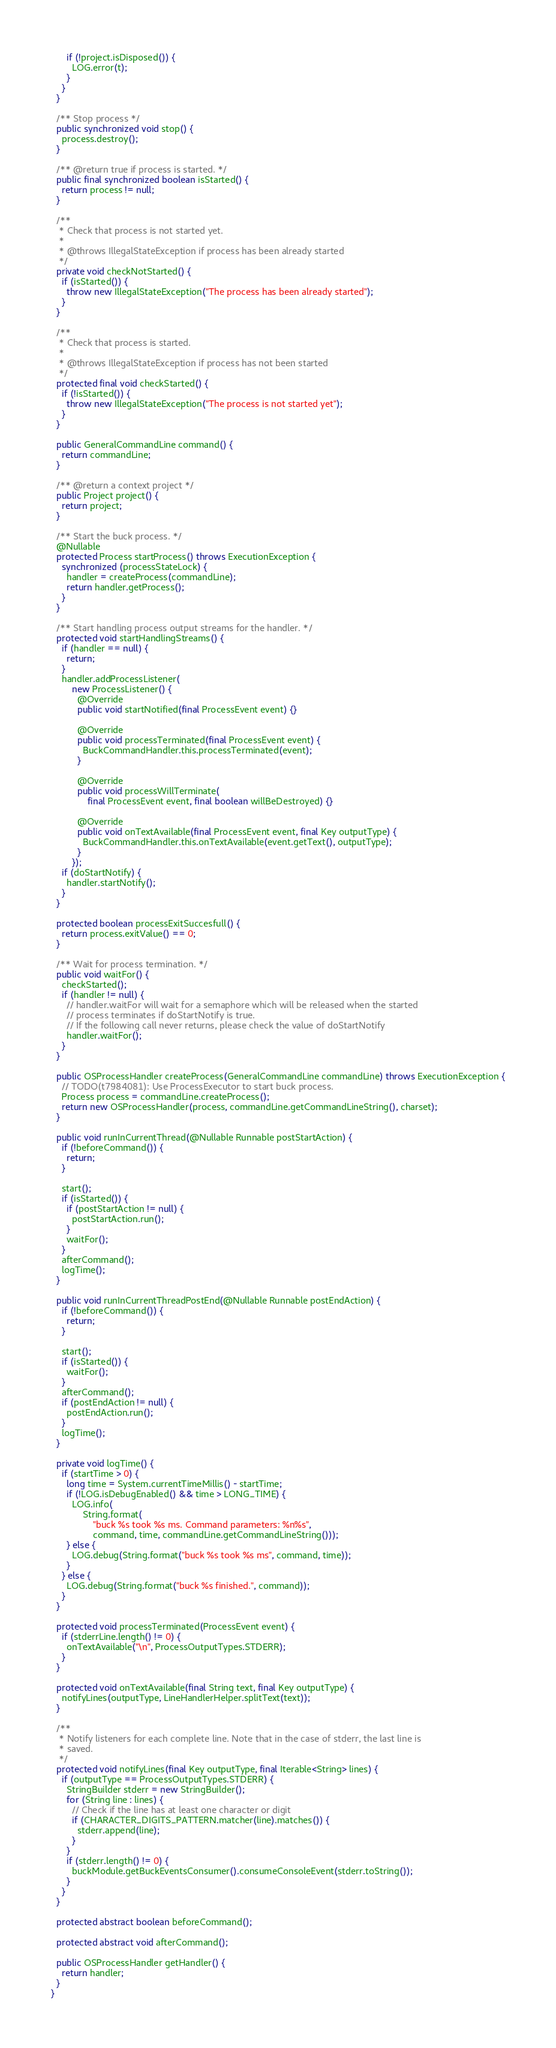<code> <loc_0><loc_0><loc_500><loc_500><_Java_>      if (!project.isDisposed()) {
        LOG.error(t);
      }
    }
  }

  /** Stop process */
  public synchronized void stop() {
    process.destroy();
  }

  /** @return true if process is started. */
  public final synchronized boolean isStarted() {
    return process != null;
  }

  /**
   * Check that process is not started yet.
   *
   * @throws IllegalStateException if process has been already started
   */
  private void checkNotStarted() {
    if (isStarted()) {
      throw new IllegalStateException("The process has been already started");
    }
  }

  /**
   * Check that process is started.
   *
   * @throws IllegalStateException if process has not been started
   */
  protected final void checkStarted() {
    if (!isStarted()) {
      throw new IllegalStateException("The process is not started yet");
    }
  }

  public GeneralCommandLine command() {
    return commandLine;
  }

  /** @return a context project */
  public Project project() {
    return project;
  }

  /** Start the buck process. */
  @Nullable
  protected Process startProcess() throws ExecutionException {
    synchronized (processStateLock) {
      handler = createProcess(commandLine);
      return handler.getProcess();
    }
  }

  /** Start handling process output streams for the handler. */
  protected void startHandlingStreams() {
    if (handler == null) {
      return;
    }
    handler.addProcessListener(
        new ProcessListener() {
          @Override
          public void startNotified(final ProcessEvent event) {}

          @Override
          public void processTerminated(final ProcessEvent event) {
            BuckCommandHandler.this.processTerminated(event);
          }

          @Override
          public void processWillTerminate(
              final ProcessEvent event, final boolean willBeDestroyed) {}

          @Override
          public void onTextAvailable(final ProcessEvent event, final Key outputType) {
            BuckCommandHandler.this.onTextAvailable(event.getText(), outputType);
          }
        });
    if (doStartNotify) {
      handler.startNotify();
    }
  }

  protected boolean processExitSuccesfull() {
    return process.exitValue() == 0;
  }

  /** Wait for process termination. */
  public void waitFor() {
    checkStarted();
    if (handler != null) {
      // handler.waitFor will wait for a semaphore which will be released when the started
      // process terminates if doStartNotify is true.
      // If the following call never returns, please check the value of doStartNotify
      handler.waitFor();
    }
  }

  public OSProcessHandler createProcess(GeneralCommandLine commandLine) throws ExecutionException {
    // TODO(t7984081): Use ProcessExecutor to start buck process.
    Process process = commandLine.createProcess();
    return new OSProcessHandler(process, commandLine.getCommandLineString(), charset);
  }

  public void runInCurrentThread(@Nullable Runnable postStartAction) {
    if (!beforeCommand()) {
      return;
    }

    start();
    if (isStarted()) {
      if (postStartAction != null) {
        postStartAction.run();
      }
      waitFor();
    }
    afterCommand();
    logTime();
  }

  public void runInCurrentThreadPostEnd(@Nullable Runnable postEndAction) {
    if (!beforeCommand()) {
      return;
    }

    start();
    if (isStarted()) {
      waitFor();
    }
    afterCommand();
    if (postEndAction != null) {
      postEndAction.run();
    }
    logTime();
  }

  private void logTime() {
    if (startTime > 0) {
      long time = System.currentTimeMillis() - startTime;
      if (!LOG.isDebugEnabled() && time > LONG_TIME) {
        LOG.info(
            String.format(
                "buck %s took %s ms. Command parameters: %n%s",
                command, time, commandLine.getCommandLineString()));
      } else {
        LOG.debug(String.format("buck %s took %s ms", command, time));
      }
    } else {
      LOG.debug(String.format("buck %s finished.", command));
    }
  }

  protected void processTerminated(ProcessEvent event) {
    if (stderrLine.length() != 0) {
      onTextAvailable("\n", ProcessOutputTypes.STDERR);
    }
  }

  protected void onTextAvailable(final String text, final Key outputType) {
    notifyLines(outputType, LineHandlerHelper.splitText(text));
  }

  /**
   * Notify listeners for each complete line. Note that in the case of stderr, the last line is
   * saved.
   */
  protected void notifyLines(final Key outputType, final Iterable<String> lines) {
    if (outputType == ProcessOutputTypes.STDERR) {
      StringBuilder stderr = new StringBuilder();
      for (String line : lines) {
        // Check if the line has at least one character or digit
        if (CHARACTER_DIGITS_PATTERN.matcher(line).matches()) {
          stderr.append(line);
        }
      }
      if (stderr.length() != 0) {
        buckModule.getBuckEventsConsumer().consumeConsoleEvent(stderr.toString());
      }
    }
  }

  protected abstract boolean beforeCommand();

  protected abstract void afterCommand();

  public OSProcessHandler getHandler() {
    return handler;
  }
}
</code> 